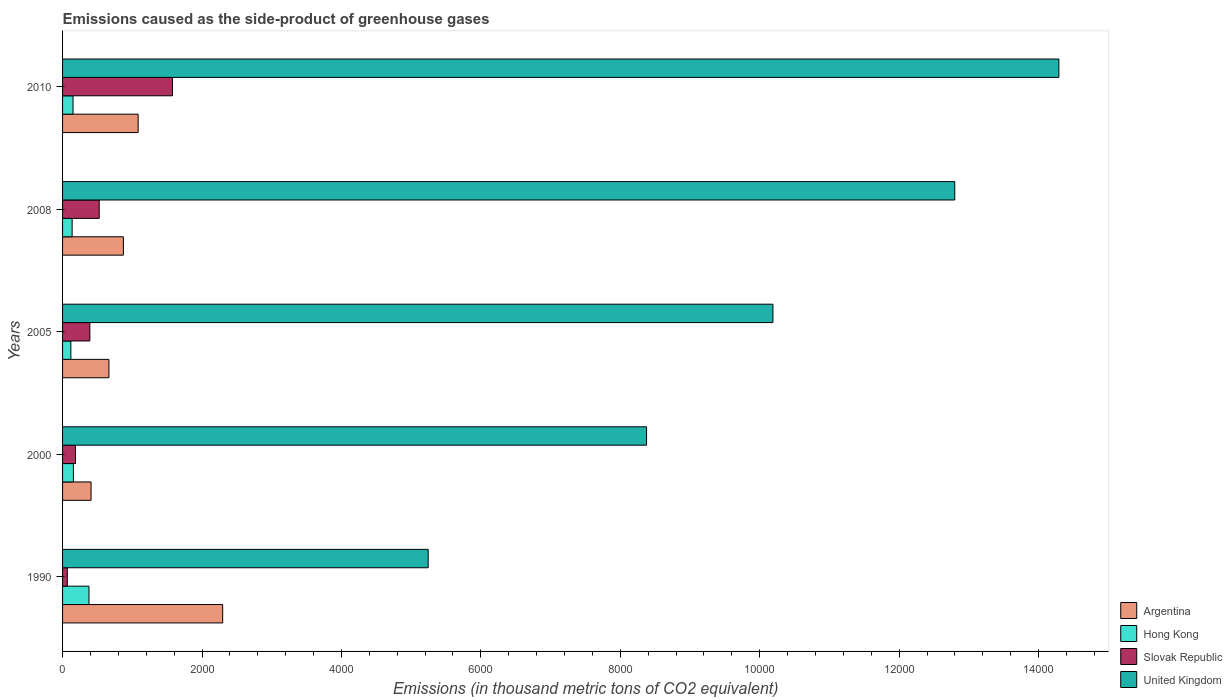How many different coloured bars are there?
Offer a terse response. 4. How many groups of bars are there?
Keep it short and to the point. 5. Are the number of bars on each tick of the Y-axis equal?
Keep it short and to the point. Yes. How many bars are there on the 4th tick from the top?
Keep it short and to the point. 4. How many bars are there on the 1st tick from the bottom?
Provide a succinct answer. 4. In how many cases, is the number of bars for a given year not equal to the number of legend labels?
Your answer should be very brief. 0. What is the emissions caused as the side-product of greenhouse gases in Argentina in 2010?
Your answer should be very brief. 1084. Across all years, what is the maximum emissions caused as the side-product of greenhouse gases in Argentina?
Keep it short and to the point. 2296.5. Across all years, what is the minimum emissions caused as the side-product of greenhouse gases in Hong Kong?
Ensure brevity in your answer.  119. In which year was the emissions caused as the side-product of greenhouse gases in Hong Kong minimum?
Keep it short and to the point. 2005. What is the total emissions caused as the side-product of greenhouse gases in Hong Kong in the graph?
Your response must be concise. 940.7. What is the difference between the emissions caused as the side-product of greenhouse gases in United Kingdom in 1990 and that in 2000?
Your answer should be very brief. -3132.5. What is the difference between the emissions caused as the side-product of greenhouse gases in Slovak Republic in 2010 and the emissions caused as the side-product of greenhouse gases in United Kingdom in 2000?
Your answer should be very brief. -6800.7. What is the average emissions caused as the side-product of greenhouse gases in Hong Kong per year?
Make the answer very short. 188.14. In the year 2010, what is the difference between the emissions caused as the side-product of greenhouse gases in United Kingdom and emissions caused as the side-product of greenhouse gases in Slovak Republic?
Provide a succinct answer. 1.27e+04. In how many years, is the emissions caused as the side-product of greenhouse gases in Hong Kong greater than 5600 thousand metric tons?
Offer a terse response. 0. What is the ratio of the emissions caused as the side-product of greenhouse gases in Slovak Republic in 2005 to that in 2010?
Your answer should be very brief. 0.25. Is the difference between the emissions caused as the side-product of greenhouse gases in United Kingdom in 2008 and 2010 greater than the difference between the emissions caused as the side-product of greenhouse gases in Slovak Republic in 2008 and 2010?
Offer a terse response. No. What is the difference between the highest and the second highest emissions caused as the side-product of greenhouse gases in Hong Kong?
Your answer should be very brief. 223.7. What is the difference between the highest and the lowest emissions caused as the side-product of greenhouse gases in Hong Kong?
Give a very brief answer. 260. In how many years, is the emissions caused as the side-product of greenhouse gases in Hong Kong greater than the average emissions caused as the side-product of greenhouse gases in Hong Kong taken over all years?
Keep it short and to the point. 1. Is the sum of the emissions caused as the side-product of greenhouse gases in Slovak Republic in 2005 and 2008 greater than the maximum emissions caused as the side-product of greenhouse gases in United Kingdom across all years?
Your answer should be compact. No. What does the 2nd bar from the top in 2005 represents?
Ensure brevity in your answer.  Slovak Republic. What does the 2nd bar from the bottom in 1990 represents?
Offer a terse response. Hong Kong. Is it the case that in every year, the sum of the emissions caused as the side-product of greenhouse gases in Hong Kong and emissions caused as the side-product of greenhouse gases in United Kingdom is greater than the emissions caused as the side-product of greenhouse gases in Argentina?
Your response must be concise. Yes. How many bars are there?
Provide a succinct answer. 20. Are the values on the major ticks of X-axis written in scientific E-notation?
Give a very brief answer. No. Where does the legend appear in the graph?
Ensure brevity in your answer.  Bottom right. How many legend labels are there?
Your response must be concise. 4. What is the title of the graph?
Offer a very short reply. Emissions caused as the side-product of greenhouse gases. Does "Equatorial Guinea" appear as one of the legend labels in the graph?
Your response must be concise. No. What is the label or title of the X-axis?
Your answer should be very brief. Emissions (in thousand metric tons of CO2 equivalent). What is the label or title of the Y-axis?
Provide a short and direct response. Years. What is the Emissions (in thousand metric tons of CO2 equivalent) of Argentina in 1990?
Your answer should be compact. 2296.5. What is the Emissions (in thousand metric tons of CO2 equivalent) in Hong Kong in 1990?
Offer a terse response. 379. What is the Emissions (in thousand metric tons of CO2 equivalent) of Slovak Republic in 1990?
Offer a terse response. 68.3. What is the Emissions (in thousand metric tons of CO2 equivalent) of United Kingdom in 1990?
Your response must be concise. 5244.2. What is the Emissions (in thousand metric tons of CO2 equivalent) in Argentina in 2000?
Provide a succinct answer. 408.8. What is the Emissions (in thousand metric tons of CO2 equivalent) in Hong Kong in 2000?
Make the answer very short. 155.3. What is the Emissions (in thousand metric tons of CO2 equivalent) of Slovak Republic in 2000?
Give a very brief answer. 185.6. What is the Emissions (in thousand metric tons of CO2 equivalent) in United Kingdom in 2000?
Your answer should be very brief. 8376.7. What is the Emissions (in thousand metric tons of CO2 equivalent) in Argentina in 2005?
Provide a short and direct response. 664.9. What is the Emissions (in thousand metric tons of CO2 equivalent) in Hong Kong in 2005?
Your answer should be very brief. 119. What is the Emissions (in thousand metric tons of CO2 equivalent) in Slovak Republic in 2005?
Ensure brevity in your answer.  391.3. What is the Emissions (in thousand metric tons of CO2 equivalent) in United Kingdom in 2005?
Offer a very short reply. 1.02e+04. What is the Emissions (in thousand metric tons of CO2 equivalent) in Argentina in 2008?
Ensure brevity in your answer.  872.4. What is the Emissions (in thousand metric tons of CO2 equivalent) in Hong Kong in 2008?
Your answer should be compact. 137.4. What is the Emissions (in thousand metric tons of CO2 equivalent) of Slovak Republic in 2008?
Give a very brief answer. 525.8. What is the Emissions (in thousand metric tons of CO2 equivalent) in United Kingdom in 2008?
Your answer should be compact. 1.28e+04. What is the Emissions (in thousand metric tons of CO2 equivalent) in Argentina in 2010?
Your answer should be compact. 1084. What is the Emissions (in thousand metric tons of CO2 equivalent) in Hong Kong in 2010?
Your answer should be compact. 150. What is the Emissions (in thousand metric tons of CO2 equivalent) of Slovak Republic in 2010?
Give a very brief answer. 1576. What is the Emissions (in thousand metric tons of CO2 equivalent) in United Kingdom in 2010?
Offer a terse response. 1.43e+04. Across all years, what is the maximum Emissions (in thousand metric tons of CO2 equivalent) of Argentina?
Make the answer very short. 2296.5. Across all years, what is the maximum Emissions (in thousand metric tons of CO2 equivalent) of Hong Kong?
Provide a succinct answer. 379. Across all years, what is the maximum Emissions (in thousand metric tons of CO2 equivalent) in Slovak Republic?
Provide a succinct answer. 1576. Across all years, what is the maximum Emissions (in thousand metric tons of CO2 equivalent) in United Kingdom?
Provide a succinct answer. 1.43e+04. Across all years, what is the minimum Emissions (in thousand metric tons of CO2 equivalent) in Argentina?
Keep it short and to the point. 408.8. Across all years, what is the minimum Emissions (in thousand metric tons of CO2 equivalent) in Hong Kong?
Offer a very short reply. 119. Across all years, what is the minimum Emissions (in thousand metric tons of CO2 equivalent) of Slovak Republic?
Offer a terse response. 68.3. Across all years, what is the minimum Emissions (in thousand metric tons of CO2 equivalent) of United Kingdom?
Provide a short and direct response. 5244.2. What is the total Emissions (in thousand metric tons of CO2 equivalent) in Argentina in the graph?
Ensure brevity in your answer.  5326.6. What is the total Emissions (in thousand metric tons of CO2 equivalent) in Hong Kong in the graph?
Your answer should be compact. 940.7. What is the total Emissions (in thousand metric tons of CO2 equivalent) of Slovak Republic in the graph?
Keep it short and to the point. 2747. What is the total Emissions (in thousand metric tons of CO2 equivalent) of United Kingdom in the graph?
Your response must be concise. 5.09e+04. What is the difference between the Emissions (in thousand metric tons of CO2 equivalent) in Argentina in 1990 and that in 2000?
Your response must be concise. 1887.7. What is the difference between the Emissions (in thousand metric tons of CO2 equivalent) in Hong Kong in 1990 and that in 2000?
Make the answer very short. 223.7. What is the difference between the Emissions (in thousand metric tons of CO2 equivalent) in Slovak Republic in 1990 and that in 2000?
Make the answer very short. -117.3. What is the difference between the Emissions (in thousand metric tons of CO2 equivalent) of United Kingdom in 1990 and that in 2000?
Provide a succinct answer. -3132.5. What is the difference between the Emissions (in thousand metric tons of CO2 equivalent) of Argentina in 1990 and that in 2005?
Your response must be concise. 1631.6. What is the difference between the Emissions (in thousand metric tons of CO2 equivalent) of Hong Kong in 1990 and that in 2005?
Your answer should be compact. 260. What is the difference between the Emissions (in thousand metric tons of CO2 equivalent) in Slovak Republic in 1990 and that in 2005?
Provide a short and direct response. -323. What is the difference between the Emissions (in thousand metric tons of CO2 equivalent) in United Kingdom in 1990 and that in 2005?
Offer a very short reply. -4944.8. What is the difference between the Emissions (in thousand metric tons of CO2 equivalent) in Argentina in 1990 and that in 2008?
Your answer should be very brief. 1424.1. What is the difference between the Emissions (in thousand metric tons of CO2 equivalent) of Hong Kong in 1990 and that in 2008?
Make the answer very short. 241.6. What is the difference between the Emissions (in thousand metric tons of CO2 equivalent) in Slovak Republic in 1990 and that in 2008?
Make the answer very short. -457.5. What is the difference between the Emissions (in thousand metric tons of CO2 equivalent) in United Kingdom in 1990 and that in 2008?
Your answer should be compact. -7553.1. What is the difference between the Emissions (in thousand metric tons of CO2 equivalent) of Argentina in 1990 and that in 2010?
Your answer should be very brief. 1212.5. What is the difference between the Emissions (in thousand metric tons of CO2 equivalent) of Hong Kong in 1990 and that in 2010?
Make the answer very short. 229. What is the difference between the Emissions (in thousand metric tons of CO2 equivalent) in Slovak Republic in 1990 and that in 2010?
Provide a short and direct response. -1507.7. What is the difference between the Emissions (in thousand metric tons of CO2 equivalent) of United Kingdom in 1990 and that in 2010?
Give a very brief answer. -9046.8. What is the difference between the Emissions (in thousand metric tons of CO2 equivalent) in Argentina in 2000 and that in 2005?
Your answer should be very brief. -256.1. What is the difference between the Emissions (in thousand metric tons of CO2 equivalent) in Hong Kong in 2000 and that in 2005?
Your answer should be very brief. 36.3. What is the difference between the Emissions (in thousand metric tons of CO2 equivalent) of Slovak Republic in 2000 and that in 2005?
Your answer should be very brief. -205.7. What is the difference between the Emissions (in thousand metric tons of CO2 equivalent) in United Kingdom in 2000 and that in 2005?
Provide a succinct answer. -1812.3. What is the difference between the Emissions (in thousand metric tons of CO2 equivalent) of Argentina in 2000 and that in 2008?
Make the answer very short. -463.6. What is the difference between the Emissions (in thousand metric tons of CO2 equivalent) of Slovak Republic in 2000 and that in 2008?
Offer a very short reply. -340.2. What is the difference between the Emissions (in thousand metric tons of CO2 equivalent) in United Kingdom in 2000 and that in 2008?
Provide a short and direct response. -4420.6. What is the difference between the Emissions (in thousand metric tons of CO2 equivalent) of Argentina in 2000 and that in 2010?
Offer a very short reply. -675.2. What is the difference between the Emissions (in thousand metric tons of CO2 equivalent) in Hong Kong in 2000 and that in 2010?
Offer a terse response. 5.3. What is the difference between the Emissions (in thousand metric tons of CO2 equivalent) in Slovak Republic in 2000 and that in 2010?
Provide a short and direct response. -1390.4. What is the difference between the Emissions (in thousand metric tons of CO2 equivalent) in United Kingdom in 2000 and that in 2010?
Your answer should be very brief. -5914.3. What is the difference between the Emissions (in thousand metric tons of CO2 equivalent) of Argentina in 2005 and that in 2008?
Provide a short and direct response. -207.5. What is the difference between the Emissions (in thousand metric tons of CO2 equivalent) of Hong Kong in 2005 and that in 2008?
Your response must be concise. -18.4. What is the difference between the Emissions (in thousand metric tons of CO2 equivalent) in Slovak Republic in 2005 and that in 2008?
Provide a succinct answer. -134.5. What is the difference between the Emissions (in thousand metric tons of CO2 equivalent) of United Kingdom in 2005 and that in 2008?
Keep it short and to the point. -2608.3. What is the difference between the Emissions (in thousand metric tons of CO2 equivalent) of Argentina in 2005 and that in 2010?
Offer a very short reply. -419.1. What is the difference between the Emissions (in thousand metric tons of CO2 equivalent) of Hong Kong in 2005 and that in 2010?
Provide a short and direct response. -31. What is the difference between the Emissions (in thousand metric tons of CO2 equivalent) in Slovak Republic in 2005 and that in 2010?
Make the answer very short. -1184.7. What is the difference between the Emissions (in thousand metric tons of CO2 equivalent) of United Kingdom in 2005 and that in 2010?
Keep it short and to the point. -4102. What is the difference between the Emissions (in thousand metric tons of CO2 equivalent) of Argentina in 2008 and that in 2010?
Your answer should be compact. -211.6. What is the difference between the Emissions (in thousand metric tons of CO2 equivalent) of Slovak Republic in 2008 and that in 2010?
Make the answer very short. -1050.2. What is the difference between the Emissions (in thousand metric tons of CO2 equivalent) of United Kingdom in 2008 and that in 2010?
Offer a very short reply. -1493.7. What is the difference between the Emissions (in thousand metric tons of CO2 equivalent) of Argentina in 1990 and the Emissions (in thousand metric tons of CO2 equivalent) of Hong Kong in 2000?
Make the answer very short. 2141.2. What is the difference between the Emissions (in thousand metric tons of CO2 equivalent) in Argentina in 1990 and the Emissions (in thousand metric tons of CO2 equivalent) in Slovak Republic in 2000?
Provide a succinct answer. 2110.9. What is the difference between the Emissions (in thousand metric tons of CO2 equivalent) in Argentina in 1990 and the Emissions (in thousand metric tons of CO2 equivalent) in United Kingdom in 2000?
Provide a succinct answer. -6080.2. What is the difference between the Emissions (in thousand metric tons of CO2 equivalent) of Hong Kong in 1990 and the Emissions (in thousand metric tons of CO2 equivalent) of Slovak Republic in 2000?
Ensure brevity in your answer.  193.4. What is the difference between the Emissions (in thousand metric tons of CO2 equivalent) of Hong Kong in 1990 and the Emissions (in thousand metric tons of CO2 equivalent) of United Kingdom in 2000?
Provide a succinct answer. -7997.7. What is the difference between the Emissions (in thousand metric tons of CO2 equivalent) in Slovak Republic in 1990 and the Emissions (in thousand metric tons of CO2 equivalent) in United Kingdom in 2000?
Offer a very short reply. -8308.4. What is the difference between the Emissions (in thousand metric tons of CO2 equivalent) in Argentina in 1990 and the Emissions (in thousand metric tons of CO2 equivalent) in Hong Kong in 2005?
Offer a terse response. 2177.5. What is the difference between the Emissions (in thousand metric tons of CO2 equivalent) in Argentina in 1990 and the Emissions (in thousand metric tons of CO2 equivalent) in Slovak Republic in 2005?
Ensure brevity in your answer.  1905.2. What is the difference between the Emissions (in thousand metric tons of CO2 equivalent) of Argentina in 1990 and the Emissions (in thousand metric tons of CO2 equivalent) of United Kingdom in 2005?
Provide a succinct answer. -7892.5. What is the difference between the Emissions (in thousand metric tons of CO2 equivalent) in Hong Kong in 1990 and the Emissions (in thousand metric tons of CO2 equivalent) in United Kingdom in 2005?
Give a very brief answer. -9810. What is the difference between the Emissions (in thousand metric tons of CO2 equivalent) of Slovak Republic in 1990 and the Emissions (in thousand metric tons of CO2 equivalent) of United Kingdom in 2005?
Make the answer very short. -1.01e+04. What is the difference between the Emissions (in thousand metric tons of CO2 equivalent) in Argentina in 1990 and the Emissions (in thousand metric tons of CO2 equivalent) in Hong Kong in 2008?
Your answer should be very brief. 2159.1. What is the difference between the Emissions (in thousand metric tons of CO2 equivalent) in Argentina in 1990 and the Emissions (in thousand metric tons of CO2 equivalent) in Slovak Republic in 2008?
Your answer should be very brief. 1770.7. What is the difference between the Emissions (in thousand metric tons of CO2 equivalent) in Argentina in 1990 and the Emissions (in thousand metric tons of CO2 equivalent) in United Kingdom in 2008?
Provide a short and direct response. -1.05e+04. What is the difference between the Emissions (in thousand metric tons of CO2 equivalent) of Hong Kong in 1990 and the Emissions (in thousand metric tons of CO2 equivalent) of Slovak Republic in 2008?
Provide a succinct answer. -146.8. What is the difference between the Emissions (in thousand metric tons of CO2 equivalent) in Hong Kong in 1990 and the Emissions (in thousand metric tons of CO2 equivalent) in United Kingdom in 2008?
Provide a short and direct response. -1.24e+04. What is the difference between the Emissions (in thousand metric tons of CO2 equivalent) in Slovak Republic in 1990 and the Emissions (in thousand metric tons of CO2 equivalent) in United Kingdom in 2008?
Offer a terse response. -1.27e+04. What is the difference between the Emissions (in thousand metric tons of CO2 equivalent) of Argentina in 1990 and the Emissions (in thousand metric tons of CO2 equivalent) of Hong Kong in 2010?
Your answer should be compact. 2146.5. What is the difference between the Emissions (in thousand metric tons of CO2 equivalent) in Argentina in 1990 and the Emissions (in thousand metric tons of CO2 equivalent) in Slovak Republic in 2010?
Your answer should be very brief. 720.5. What is the difference between the Emissions (in thousand metric tons of CO2 equivalent) in Argentina in 1990 and the Emissions (in thousand metric tons of CO2 equivalent) in United Kingdom in 2010?
Ensure brevity in your answer.  -1.20e+04. What is the difference between the Emissions (in thousand metric tons of CO2 equivalent) of Hong Kong in 1990 and the Emissions (in thousand metric tons of CO2 equivalent) of Slovak Republic in 2010?
Keep it short and to the point. -1197. What is the difference between the Emissions (in thousand metric tons of CO2 equivalent) of Hong Kong in 1990 and the Emissions (in thousand metric tons of CO2 equivalent) of United Kingdom in 2010?
Your answer should be compact. -1.39e+04. What is the difference between the Emissions (in thousand metric tons of CO2 equivalent) of Slovak Republic in 1990 and the Emissions (in thousand metric tons of CO2 equivalent) of United Kingdom in 2010?
Provide a short and direct response. -1.42e+04. What is the difference between the Emissions (in thousand metric tons of CO2 equivalent) of Argentina in 2000 and the Emissions (in thousand metric tons of CO2 equivalent) of Hong Kong in 2005?
Ensure brevity in your answer.  289.8. What is the difference between the Emissions (in thousand metric tons of CO2 equivalent) of Argentina in 2000 and the Emissions (in thousand metric tons of CO2 equivalent) of Slovak Republic in 2005?
Ensure brevity in your answer.  17.5. What is the difference between the Emissions (in thousand metric tons of CO2 equivalent) in Argentina in 2000 and the Emissions (in thousand metric tons of CO2 equivalent) in United Kingdom in 2005?
Keep it short and to the point. -9780.2. What is the difference between the Emissions (in thousand metric tons of CO2 equivalent) in Hong Kong in 2000 and the Emissions (in thousand metric tons of CO2 equivalent) in Slovak Republic in 2005?
Offer a terse response. -236. What is the difference between the Emissions (in thousand metric tons of CO2 equivalent) of Hong Kong in 2000 and the Emissions (in thousand metric tons of CO2 equivalent) of United Kingdom in 2005?
Provide a short and direct response. -1.00e+04. What is the difference between the Emissions (in thousand metric tons of CO2 equivalent) in Slovak Republic in 2000 and the Emissions (in thousand metric tons of CO2 equivalent) in United Kingdom in 2005?
Your answer should be very brief. -1.00e+04. What is the difference between the Emissions (in thousand metric tons of CO2 equivalent) of Argentina in 2000 and the Emissions (in thousand metric tons of CO2 equivalent) of Hong Kong in 2008?
Your answer should be very brief. 271.4. What is the difference between the Emissions (in thousand metric tons of CO2 equivalent) of Argentina in 2000 and the Emissions (in thousand metric tons of CO2 equivalent) of Slovak Republic in 2008?
Keep it short and to the point. -117. What is the difference between the Emissions (in thousand metric tons of CO2 equivalent) of Argentina in 2000 and the Emissions (in thousand metric tons of CO2 equivalent) of United Kingdom in 2008?
Your answer should be very brief. -1.24e+04. What is the difference between the Emissions (in thousand metric tons of CO2 equivalent) in Hong Kong in 2000 and the Emissions (in thousand metric tons of CO2 equivalent) in Slovak Republic in 2008?
Your response must be concise. -370.5. What is the difference between the Emissions (in thousand metric tons of CO2 equivalent) of Hong Kong in 2000 and the Emissions (in thousand metric tons of CO2 equivalent) of United Kingdom in 2008?
Provide a succinct answer. -1.26e+04. What is the difference between the Emissions (in thousand metric tons of CO2 equivalent) in Slovak Republic in 2000 and the Emissions (in thousand metric tons of CO2 equivalent) in United Kingdom in 2008?
Provide a succinct answer. -1.26e+04. What is the difference between the Emissions (in thousand metric tons of CO2 equivalent) of Argentina in 2000 and the Emissions (in thousand metric tons of CO2 equivalent) of Hong Kong in 2010?
Provide a succinct answer. 258.8. What is the difference between the Emissions (in thousand metric tons of CO2 equivalent) of Argentina in 2000 and the Emissions (in thousand metric tons of CO2 equivalent) of Slovak Republic in 2010?
Your answer should be compact. -1167.2. What is the difference between the Emissions (in thousand metric tons of CO2 equivalent) of Argentina in 2000 and the Emissions (in thousand metric tons of CO2 equivalent) of United Kingdom in 2010?
Give a very brief answer. -1.39e+04. What is the difference between the Emissions (in thousand metric tons of CO2 equivalent) of Hong Kong in 2000 and the Emissions (in thousand metric tons of CO2 equivalent) of Slovak Republic in 2010?
Your answer should be compact. -1420.7. What is the difference between the Emissions (in thousand metric tons of CO2 equivalent) of Hong Kong in 2000 and the Emissions (in thousand metric tons of CO2 equivalent) of United Kingdom in 2010?
Make the answer very short. -1.41e+04. What is the difference between the Emissions (in thousand metric tons of CO2 equivalent) of Slovak Republic in 2000 and the Emissions (in thousand metric tons of CO2 equivalent) of United Kingdom in 2010?
Give a very brief answer. -1.41e+04. What is the difference between the Emissions (in thousand metric tons of CO2 equivalent) of Argentina in 2005 and the Emissions (in thousand metric tons of CO2 equivalent) of Hong Kong in 2008?
Offer a very short reply. 527.5. What is the difference between the Emissions (in thousand metric tons of CO2 equivalent) of Argentina in 2005 and the Emissions (in thousand metric tons of CO2 equivalent) of Slovak Republic in 2008?
Ensure brevity in your answer.  139.1. What is the difference between the Emissions (in thousand metric tons of CO2 equivalent) of Argentina in 2005 and the Emissions (in thousand metric tons of CO2 equivalent) of United Kingdom in 2008?
Provide a short and direct response. -1.21e+04. What is the difference between the Emissions (in thousand metric tons of CO2 equivalent) in Hong Kong in 2005 and the Emissions (in thousand metric tons of CO2 equivalent) in Slovak Republic in 2008?
Ensure brevity in your answer.  -406.8. What is the difference between the Emissions (in thousand metric tons of CO2 equivalent) of Hong Kong in 2005 and the Emissions (in thousand metric tons of CO2 equivalent) of United Kingdom in 2008?
Provide a succinct answer. -1.27e+04. What is the difference between the Emissions (in thousand metric tons of CO2 equivalent) of Slovak Republic in 2005 and the Emissions (in thousand metric tons of CO2 equivalent) of United Kingdom in 2008?
Keep it short and to the point. -1.24e+04. What is the difference between the Emissions (in thousand metric tons of CO2 equivalent) of Argentina in 2005 and the Emissions (in thousand metric tons of CO2 equivalent) of Hong Kong in 2010?
Make the answer very short. 514.9. What is the difference between the Emissions (in thousand metric tons of CO2 equivalent) of Argentina in 2005 and the Emissions (in thousand metric tons of CO2 equivalent) of Slovak Republic in 2010?
Your answer should be compact. -911.1. What is the difference between the Emissions (in thousand metric tons of CO2 equivalent) of Argentina in 2005 and the Emissions (in thousand metric tons of CO2 equivalent) of United Kingdom in 2010?
Offer a very short reply. -1.36e+04. What is the difference between the Emissions (in thousand metric tons of CO2 equivalent) in Hong Kong in 2005 and the Emissions (in thousand metric tons of CO2 equivalent) in Slovak Republic in 2010?
Keep it short and to the point. -1457. What is the difference between the Emissions (in thousand metric tons of CO2 equivalent) in Hong Kong in 2005 and the Emissions (in thousand metric tons of CO2 equivalent) in United Kingdom in 2010?
Provide a short and direct response. -1.42e+04. What is the difference between the Emissions (in thousand metric tons of CO2 equivalent) in Slovak Republic in 2005 and the Emissions (in thousand metric tons of CO2 equivalent) in United Kingdom in 2010?
Your answer should be very brief. -1.39e+04. What is the difference between the Emissions (in thousand metric tons of CO2 equivalent) in Argentina in 2008 and the Emissions (in thousand metric tons of CO2 equivalent) in Hong Kong in 2010?
Keep it short and to the point. 722.4. What is the difference between the Emissions (in thousand metric tons of CO2 equivalent) in Argentina in 2008 and the Emissions (in thousand metric tons of CO2 equivalent) in Slovak Republic in 2010?
Offer a very short reply. -703.6. What is the difference between the Emissions (in thousand metric tons of CO2 equivalent) of Argentina in 2008 and the Emissions (in thousand metric tons of CO2 equivalent) of United Kingdom in 2010?
Make the answer very short. -1.34e+04. What is the difference between the Emissions (in thousand metric tons of CO2 equivalent) in Hong Kong in 2008 and the Emissions (in thousand metric tons of CO2 equivalent) in Slovak Republic in 2010?
Provide a short and direct response. -1438.6. What is the difference between the Emissions (in thousand metric tons of CO2 equivalent) in Hong Kong in 2008 and the Emissions (in thousand metric tons of CO2 equivalent) in United Kingdom in 2010?
Give a very brief answer. -1.42e+04. What is the difference between the Emissions (in thousand metric tons of CO2 equivalent) in Slovak Republic in 2008 and the Emissions (in thousand metric tons of CO2 equivalent) in United Kingdom in 2010?
Your answer should be compact. -1.38e+04. What is the average Emissions (in thousand metric tons of CO2 equivalent) in Argentina per year?
Give a very brief answer. 1065.32. What is the average Emissions (in thousand metric tons of CO2 equivalent) of Hong Kong per year?
Offer a terse response. 188.14. What is the average Emissions (in thousand metric tons of CO2 equivalent) in Slovak Republic per year?
Provide a succinct answer. 549.4. What is the average Emissions (in thousand metric tons of CO2 equivalent) of United Kingdom per year?
Keep it short and to the point. 1.02e+04. In the year 1990, what is the difference between the Emissions (in thousand metric tons of CO2 equivalent) in Argentina and Emissions (in thousand metric tons of CO2 equivalent) in Hong Kong?
Offer a very short reply. 1917.5. In the year 1990, what is the difference between the Emissions (in thousand metric tons of CO2 equivalent) of Argentina and Emissions (in thousand metric tons of CO2 equivalent) of Slovak Republic?
Keep it short and to the point. 2228.2. In the year 1990, what is the difference between the Emissions (in thousand metric tons of CO2 equivalent) of Argentina and Emissions (in thousand metric tons of CO2 equivalent) of United Kingdom?
Offer a terse response. -2947.7. In the year 1990, what is the difference between the Emissions (in thousand metric tons of CO2 equivalent) of Hong Kong and Emissions (in thousand metric tons of CO2 equivalent) of Slovak Republic?
Your answer should be very brief. 310.7. In the year 1990, what is the difference between the Emissions (in thousand metric tons of CO2 equivalent) of Hong Kong and Emissions (in thousand metric tons of CO2 equivalent) of United Kingdom?
Ensure brevity in your answer.  -4865.2. In the year 1990, what is the difference between the Emissions (in thousand metric tons of CO2 equivalent) in Slovak Republic and Emissions (in thousand metric tons of CO2 equivalent) in United Kingdom?
Provide a short and direct response. -5175.9. In the year 2000, what is the difference between the Emissions (in thousand metric tons of CO2 equivalent) of Argentina and Emissions (in thousand metric tons of CO2 equivalent) of Hong Kong?
Ensure brevity in your answer.  253.5. In the year 2000, what is the difference between the Emissions (in thousand metric tons of CO2 equivalent) of Argentina and Emissions (in thousand metric tons of CO2 equivalent) of Slovak Republic?
Offer a terse response. 223.2. In the year 2000, what is the difference between the Emissions (in thousand metric tons of CO2 equivalent) in Argentina and Emissions (in thousand metric tons of CO2 equivalent) in United Kingdom?
Your answer should be very brief. -7967.9. In the year 2000, what is the difference between the Emissions (in thousand metric tons of CO2 equivalent) in Hong Kong and Emissions (in thousand metric tons of CO2 equivalent) in Slovak Republic?
Offer a terse response. -30.3. In the year 2000, what is the difference between the Emissions (in thousand metric tons of CO2 equivalent) in Hong Kong and Emissions (in thousand metric tons of CO2 equivalent) in United Kingdom?
Give a very brief answer. -8221.4. In the year 2000, what is the difference between the Emissions (in thousand metric tons of CO2 equivalent) in Slovak Republic and Emissions (in thousand metric tons of CO2 equivalent) in United Kingdom?
Keep it short and to the point. -8191.1. In the year 2005, what is the difference between the Emissions (in thousand metric tons of CO2 equivalent) in Argentina and Emissions (in thousand metric tons of CO2 equivalent) in Hong Kong?
Give a very brief answer. 545.9. In the year 2005, what is the difference between the Emissions (in thousand metric tons of CO2 equivalent) in Argentina and Emissions (in thousand metric tons of CO2 equivalent) in Slovak Republic?
Keep it short and to the point. 273.6. In the year 2005, what is the difference between the Emissions (in thousand metric tons of CO2 equivalent) of Argentina and Emissions (in thousand metric tons of CO2 equivalent) of United Kingdom?
Make the answer very short. -9524.1. In the year 2005, what is the difference between the Emissions (in thousand metric tons of CO2 equivalent) in Hong Kong and Emissions (in thousand metric tons of CO2 equivalent) in Slovak Republic?
Your answer should be very brief. -272.3. In the year 2005, what is the difference between the Emissions (in thousand metric tons of CO2 equivalent) of Hong Kong and Emissions (in thousand metric tons of CO2 equivalent) of United Kingdom?
Offer a terse response. -1.01e+04. In the year 2005, what is the difference between the Emissions (in thousand metric tons of CO2 equivalent) in Slovak Republic and Emissions (in thousand metric tons of CO2 equivalent) in United Kingdom?
Ensure brevity in your answer.  -9797.7. In the year 2008, what is the difference between the Emissions (in thousand metric tons of CO2 equivalent) in Argentina and Emissions (in thousand metric tons of CO2 equivalent) in Hong Kong?
Provide a succinct answer. 735. In the year 2008, what is the difference between the Emissions (in thousand metric tons of CO2 equivalent) in Argentina and Emissions (in thousand metric tons of CO2 equivalent) in Slovak Republic?
Your response must be concise. 346.6. In the year 2008, what is the difference between the Emissions (in thousand metric tons of CO2 equivalent) of Argentina and Emissions (in thousand metric tons of CO2 equivalent) of United Kingdom?
Make the answer very short. -1.19e+04. In the year 2008, what is the difference between the Emissions (in thousand metric tons of CO2 equivalent) of Hong Kong and Emissions (in thousand metric tons of CO2 equivalent) of Slovak Republic?
Give a very brief answer. -388.4. In the year 2008, what is the difference between the Emissions (in thousand metric tons of CO2 equivalent) in Hong Kong and Emissions (in thousand metric tons of CO2 equivalent) in United Kingdom?
Provide a short and direct response. -1.27e+04. In the year 2008, what is the difference between the Emissions (in thousand metric tons of CO2 equivalent) in Slovak Republic and Emissions (in thousand metric tons of CO2 equivalent) in United Kingdom?
Offer a terse response. -1.23e+04. In the year 2010, what is the difference between the Emissions (in thousand metric tons of CO2 equivalent) in Argentina and Emissions (in thousand metric tons of CO2 equivalent) in Hong Kong?
Provide a succinct answer. 934. In the year 2010, what is the difference between the Emissions (in thousand metric tons of CO2 equivalent) in Argentina and Emissions (in thousand metric tons of CO2 equivalent) in Slovak Republic?
Give a very brief answer. -492. In the year 2010, what is the difference between the Emissions (in thousand metric tons of CO2 equivalent) of Argentina and Emissions (in thousand metric tons of CO2 equivalent) of United Kingdom?
Provide a succinct answer. -1.32e+04. In the year 2010, what is the difference between the Emissions (in thousand metric tons of CO2 equivalent) in Hong Kong and Emissions (in thousand metric tons of CO2 equivalent) in Slovak Republic?
Your answer should be compact. -1426. In the year 2010, what is the difference between the Emissions (in thousand metric tons of CO2 equivalent) of Hong Kong and Emissions (in thousand metric tons of CO2 equivalent) of United Kingdom?
Your answer should be compact. -1.41e+04. In the year 2010, what is the difference between the Emissions (in thousand metric tons of CO2 equivalent) in Slovak Republic and Emissions (in thousand metric tons of CO2 equivalent) in United Kingdom?
Make the answer very short. -1.27e+04. What is the ratio of the Emissions (in thousand metric tons of CO2 equivalent) of Argentina in 1990 to that in 2000?
Ensure brevity in your answer.  5.62. What is the ratio of the Emissions (in thousand metric tons of CO2 equivalent) of Hong Kong in 1990 to that in 2000?
Your response must be concise. 2.44. What is the ratio of the Emissions (in thousand metric tons of CO2 equivalent) of Slovak Republic in 1990 to that in 2000?
Your answer should be very brief. 0.37. What is the ratio of the Emissions (in thousand metric tons of CO2 equivalent) of United Kingdom in 1990 to that in 2000?
Your answer should be compact. 0.63. What is the ratio of the Emissions (in thousand metric tons of CO2 equivalent) in Argentina in 1990 to that in 2005?
Offer a very short reply. 3.45. What is the ratio of the Emissions (in thousand metric tons of CO2 equivalent) of Hong Kong in 1990 to that in 2005?
Keep it short and to the point. 3.18. What is the ratio of the Emissions (in thousand metric tons of CO2 equivalent) of Slovak Republic in 1990 to that in 2005?
Ensure brevity in your answer.  0.17. What is the ratio of the Emissions (in thousand metric tons of CO2 equivalent) of United Kingdom in 1990 to that in 2005?
Your answer should be compact. 0.51. What is the ratio of the Emissions (in thousand metric tons of CO2 equivalent) of Argentina in 1990 to that in 2008?
Provide a succinct answer. 2.63. What is the ratio of the Emissions (in thousand metric tons of CO2 equivalent) of Hong Kong in 1990 to that in 2008?
Give a very brief answer. 2.76. What is the ratio of the Emissions (in thousand metric tons of CO2 equivalent) of Slovak Republic in 1990 to that in 2008?
Your response must be concise. 0.13. What is the ratio of the Emissions (in thousand metric tons of CO2 equivalent) in United Kingdom in 1990 to that in 2008?
Ensure brevity in your answer.  0.41. What is the ratio of the Emissions (in thousand metric tons of CO2 equivalent) of Argentina in 1990 to that in 2010?
Provide a succinct answer. 2.12. What is the ratio of the Emissions (in thousand metric tons of CO2 equivalent) in Hong Kong in 1990 to that in 2010?
Ensure brevity in your answer.  2.53. What is the ratio of the Emissions (in thousand metric tons of CO2 equivalent) of Slovak Republic in 1990 to that in 2010?
Your answer should be very brief. 0.04. What is the ratio of the Emissions (in thousand metric tons of CO2 equivalent) in United Kingdom in 1990 to that in 2010?
Your answer should be very brief. 0.37. What is the ratio of the Emissions (in thousand metric tons of CO2 equivalent) in Argentina in 2000 to that in 2005?
Ensure brevity in your answer.  0.61. What is the ratio of the Emissions (in thousand metric tons of CO2 equivalent) of Hong Kong in 2000 to that in 2005?
Give a very brief answer. 1.3. What is the ratio of the Emissions (in thousand metric tons of CO2 equivalent) of Slovak Republic in 2000 to that in 2005?
Ensure brevity in your answer.  0.47. What is the ratio of the Emissions (in thousand metric tons of CO2 equivalent) in United Kingdom in 2000 to that in 2005?
Give a very brief answer. 0.82. What is the ratio of the Emissions (in thousand metric tons of CO2 equivalent) of Argentina in 2000 to that in 2008?
Keep it short and to the point. 0.47. What is the ratio of the Emissions (in thousand metric tons of CO2 equivalent) of Hong Kong in 2000 to that in 2008?
Ensure brevity in your answer.  1.13. What is the ratio of the Emissions (in thousand metric tons of CO2 equivalent) in Slovak Republic in 2000 to that in 2008?
Offer a terse response. 0.35. What is the ratio of the Emissions (in thousand metric tons of CO2 equivalent) of United Kingdom in 2000 to that in 2008?
Give a very brief answer. 0.65. What is the ratio of the Emissions (in thousand metric tons of CO2 equivalent) in Argentina in 2000 to that in 2010?
Offer a terse response. 0.38. What is the ratio of the Emissions (in thousand metric tons of CO2 equivalent) of Hong Kong in 2000 to that in 2010?
Offer a very short reply. 1.04. What is the ratio of the Emissions (in thousand metric tons of CO2 equivalent) of Slovak Republic in 2000 to that in 2010?
Your answer should be very brief. 0.12. What is the ratio of the Emissions (in thousand metric tons of CO2 equivalent) of United Kingdom in 2000 to that in 2010?
Offer a terse response. 0.59. What is the ratio of the Emissions (in thousand metric tons of CO2 equivalent) in Argentina in 2005 to that in 2008?
Your answer should be compact. 0.76. What is the ratio of the Emissions (in thousand metric tons of CO2 equivalent) of Hong Kong in 2005 to that in 2008?
Your answer should be compact. 0.87. What is the ratio of the Emissions (in thousand metric tons of CO2 equivalent) of Slovak Republic in 2005 to that in 2008?
Ensure brevity in your answer.  0.74. What is the ratio of the Emissions (in thousand metric tons of CO2 equivalent) in United Kingdom in 2005 to that in 2008?
Provide a succinct answer. 0.8. What is the ratio of the Emissions (in thousand metric tons of CO2 equivalent) of Argentina in 2005 to that in 2010?
Give a very brief answer. 0.61. What is the ratio of the Emissions (in thousand metric tons of CO2 equivalent) in Hong Kong in 2005 to that in 2010?
Give a very brief answer. 0.79. What is the ratio of the Emissions (in thousand metric tons of CO2 equivalent) in Slovak Republic in 2005 to that in 2010?
Provide a succinct answer. 0.25. What is the ratio of the Emissions (in thousand metric tons of CO2 equivalent) in United Kingdom in 2005 to that in 2010?
Offer a very short reply. 0.71. What is the ratio of the Emissions (in thousand metric tons of CO2 equivalent) of Argentina in 2008 to that in 2010?
Make the answer very short. 0.8. What is the ratio of the Emissions (in thousand metric tons of CO2 equivalent) of Hong Kong in 2008 to that in 2010?
Ensure brevity in your answer.  0.92. What is the ratio of the Emissions (in thousand metric tons of CO2 equivalent) in Slovak Republic in 2008 to that in 2010?
Offer a very short reply. 0.33. What is the ratio of the Emissions (in thousand metric tons of CO2 equivalent) in United Kingdom in 2008 to that in 2010?
Give a very brief answer. 0.9. What is the difference between the highest and the second highest Emissions (in thousand metric tons of CO2 equivalent) in Argentina?
Your answer should be compact. 1212.5. What is the difference between the highest and the second highest Emissions (in thousand metric tons of CO2 equivalent) in Hong Kong?
Keep it short and to the point. 223.7. What is the difference between the highest and the second highest Emissions (in thousand metric tons of CO2 equivalent) in Slovak Republic?
Provide a succinct answer. 1050.2. What is the difference between the highest and the second highest Emissions (in thousand metric tons of CO2 equivalent) in United Kingdom?
Your response must be concise. 1493.7. What is the difference between the highest and the lowest Emissions (in thousand metric tons of CO2 equivalent) in Argentina?
Offer a very short reply. 1887.7. What is the difference between the highest and the lowest Emissions (in thousand metric tons of CO2 equivalent) in Hong Kong?
Provide a short and direct response. 260. What is the difference between the highest and the lowest Emissions (in thousand metric tons of CO2 equivalent) of Slovak Republic?
Keep it short and to the point. 1507.7. What is the difference between the highest and the lowest Emissions (in thousand metric tons of CO2 equivalent) of United Kingdom?
Your response must be concise. 9046.8. 